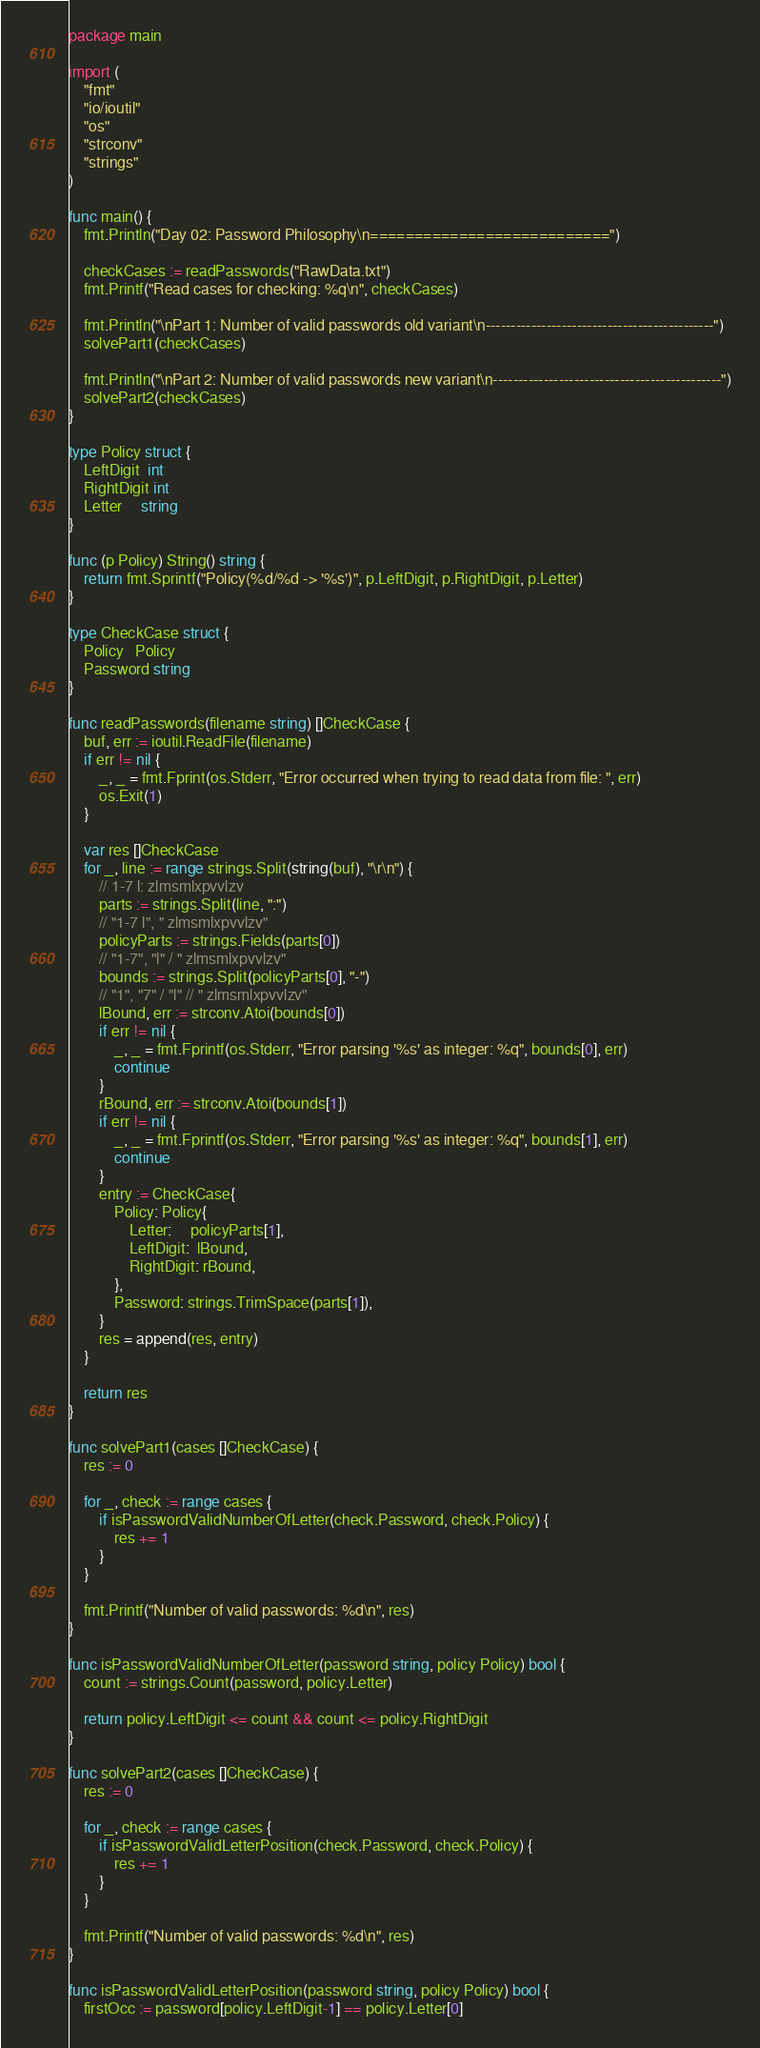Convert code to text. <code><loc_0><loc_0><loc_500><loc_500><_Go_>package main

import (
	"fmt"
	"io/ioutil"
	"os"
	"strconv"
	"strings"
)

func main() {
	fmt.Println("Day 02: Password Philosophy\n===========================")

	checkCases := readPasswords("RawData.txt")
	fmt.Printf("Read cases for checking: %q\n", checkCases)

	fmt.Println("\nPart 1: Number of valid passwords old variant\n---------------------------------------------")
	solvePart1(checkCases)

	fmt.Println("\nPart 2: Number of valid passwords new variant\n---------------------------------------------")
	solvePart2(checkCases)
}

type Policy struct {
	LeftDigit  int
	RightDigit int
	Letter     string
}

func (p Policy) String() string {
	return fmt.Sprintf("Policy(%d/%d -> '%s')", p.LeftDigit, p.RightDigit, p.Letter)
}

type CheckCase struct {
	Policy   Policy
	Password string
}

func readPasswords(filename string) []CheckCase {
	buf, err := ioutil.ReadFile(filename)
	if err != nil {
		_, _ = fmt.Fprint(os.Stderr, "Error occurred when trying to read data from file: ", err)
		os.Exit(1)
	}

	var res []CheckCase
	for _, line := range strings.Split(string(buf), "\r\n") {
		// 1-7 l: zlmsmlxpvvlzv
		parts := strings.Split(line, ":")
		// "1-7 l", " zlmsmlxpvvlzv"
		policyParts := strings.Fields(parts[0])
		// "1-7", "l" / " zlmsmlxpvvlzv"
		bounds := strings.Split(policyParts[0], "-")
		// "1", "7" / "l" // " zlmsmlxpvvlzv"
		lBound, err := strconv.Atoi(bounds[0])
		if err != nil {
			_, _ = fmt.Fprintf(os.Stderr, "Error parsing '%s' as integer: %q", bounds[0], err)
			continue
		}
		rBound, err := strconv.Atoi(bounds[1])
		if err != nil {
			_, _ = fmt.Fprintf(os.Stderr, "Error parsing '%s' as integer: %q", bounds[1], err)
			continue
		}
		entry := CheckCase{
			Policy: Policy{
				Letter:     policyParts[1],
				LeftDigit:  lBound,
				RightDigit: rBound,
			},
			Password: strings.TrimSpace(parts[1]),
		}
		res = append(res, entry)
	}

	return res
}

func solvePart1(cases []CheckCase) {
	res := 0

	for _, check := range cases {
		if isPasswordValidNumberOfLetter(check.Password, check.Policy) {
			res += 1
		}
	}

	fmt.Printf("Number of valid passwords: %d\n", res)
}

func isPasswordValidNumberOfLetter(password string, policy Policy) bool {
	count := strings.Count(password, policy.Letter)

	return policy.LeftDigit <= count && count <= policy.RightDigit
}

func solvePart2(cases []CheckCase) {
	res := 0

	for _, check := range cases {
		if isPasswordValidLetterPosition(check.Password, check.Policy) {
			res += 1
		}
	}

	fmt.Printf("Number of valid passwords: %d\n", res)
}

func isPasswordValidLetterPosition(password string, policy Policy) bool {
	firstOcc := password[policy.LeftDigit-1] == policy.Letter[0]</code> 